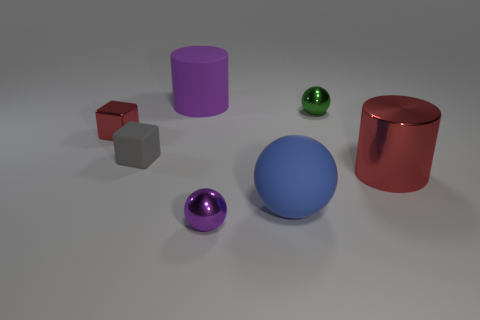Add 2 tiny metallic blocks. How many objects exist? 9 Subtract all cylinders. How many objects are left? 5 Add 7 large blue objects. How many large blue objects are left? 8 Add 1 gray things. How many gray things exist? 2 Subtract 0 cyan cubes. How many objects are left? 7 Subtract all small matte blocks. Subtract all cylinders. How many objects are left? 4 